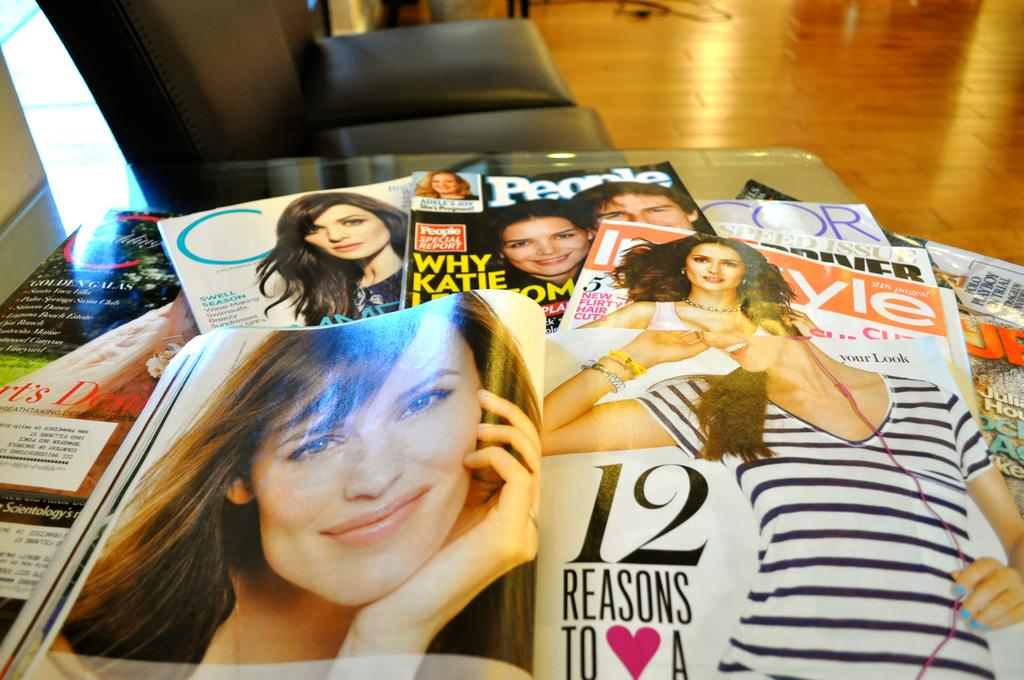What type of reading material is on the table in the image? There are magazines on the table. What type of furniture can be seen in the background of the image? There are chairs in the background of the image. What else can be seen in the background of the image? There are some objects in the background of the image. What time of day is it in the image, and how many dogs are present? The provided facts do not mention the time of day or the presence of any dogs in the image. 